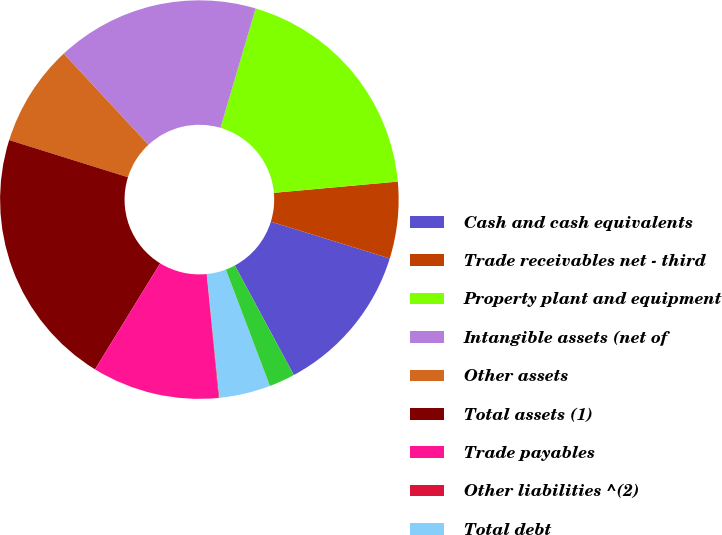<chart> <loc_0><loc_0><loc_500><loc_500><pie_chart><fcel>Cash and cash equivalents<fcel>Trade receivables net - third<fcel>Property plant and equipment<fcel>Intangible assets (net of<fcel>Other assets<fcel>Total assets (1)<fcel>Trade payables<fcel>Other liabilities ^(2)<fcel>Total debt<fcel>Deferred income taxes<nl><fcel>12.37%<fcel>6.21%<fcel>19.0%<fcel>16.47%<fcel>8.26%<fcel>21.05%<fcel>10.32%<fcel>0.05%<fcel>4.16%<fcel>2.1%<nl></chart> 